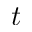Convert formula to latex. <formula><loc_0><loc_0><loc_500><loc_500>t</formula> 